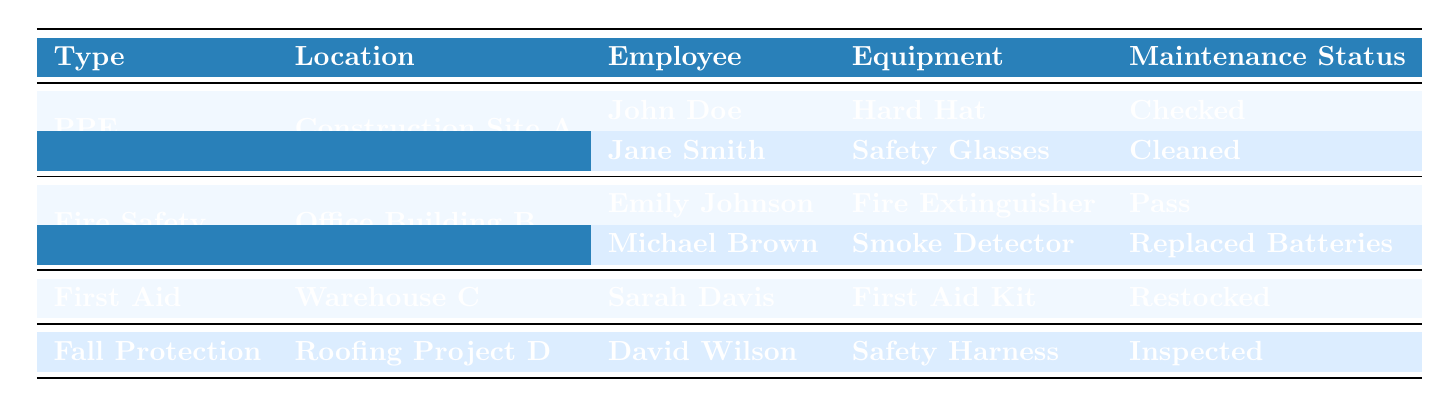What types of safety equipment are recorded in the table? The table presents four types of safety equipment: Personal Protective Equipment (PPE), Fire Safety Equipment, First Aid Kits, and Fall Protection Gear. This can be identified by looking at the "Type" column of the table.
Answer: PPE, Fire Safety Equipment, First Aid Kits, Fall Protection Gear How many employees used Personal Protective Equipment at Construction Site A? In the table, under the "PPE" type for "Construction Site A," there are two entries: John Doe and Jane Smith, indicating two employees used PPE in that location.
Answer: 2 Did Michael Brown's Smoke Detector maintenance pass? The table indicates that Michael Brown checked the Smoke Detector at Office Building B and its maintenance status was recorded as "Replaced Batteries," which implies that it had to be a successful maintenance event, but does not explicitly state “pass.” Therefore, the specific term "pass" cannot be confirmed.
Answer: No Which type of safety equipment had the most recent usage record? The most recent usage record is from David Wilson on September 15, 2023, for Fall Protection Gear (Safety Harness) at Roofing Project D. Checking the "Date" column for the last entry will confirm this date against others.
Answer: Fall Protection Gear What maintenance status did Sarah Davis report for the First Aid Kit at Warehouse C? The maintenance status for the First Aid Kit used by Sarah Davis is listed as "Restocked" in the corresponding row of the table, which is easily identifiable under the "Maintenance Status" column.
Answer: Restocked How many total usage records are present for Fire Safety Equipment? The total usage records for Fire Safety Equipment, found in the "Usage Records" of the "Fire Safety Equipment" type at Office Building B, shows two entries: one for Emily Johnson and one for Michael Brown. Therefore, there are two records for Fire Safety Equipment.
Answer: 2 Was any personal protective equipment cleaned on the same date as used? Yes, both pieces of PPE, the Hard Hat and Safety Glasses, were used on the same date, September 1, 2023. This is derived from both usage records listed under the PPE category for that date.
Answer: Yes Which piece of equipment was inspected last? The Safety Harness was inspected last on September 15, 2023, as it is the last entry in the table under "Fall Protection Gear." It can be identified by checking the "Date" column for the latest date among the equipment types.
Answer: Safety Harness What was the maintenance status of the Fire Extinguisher checked by Emily Johnson? The table shows that Emily Johnson checked the Fire Extinguisher and the maintenance status recorded was "Pass." This can be directly viewed from the corresponding row in the table.
Answer: Pass 